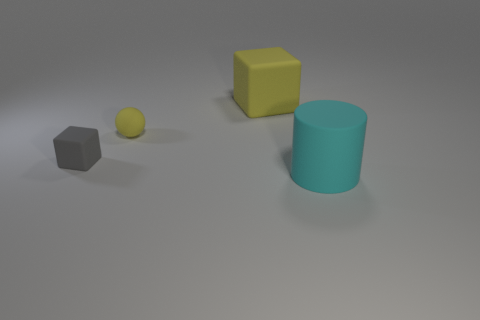Subtract all green cubes. Subtract all gray cylinders. How many cubes are left? 2 Add 3 cylinders. How many objects exist? 7 Subtract all cylinders. How many objects are left? 3 Subtract 0 blue cubes. How many objects are left? 4 Subtract all large cyan metallic cubes. Subtract all large yellow matte objects. How many objects are left? 3 Add 2 matte balls. How many matte balls are left? 3 Add 3 small blue metal blocks. How many small blue metal blocks exist? 3 